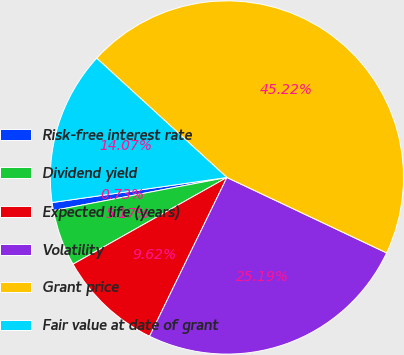Convert chart to OTSL. <chart><loc_0><loc_0><loc_500><loc_500><pie_chart><fcel>Risk-free interest rate<fcel>Dividend yield<fcel>Expected life (years)<fcel>Volatility<fcel>Grant price<fcel>Fair value at date of grant<nl><fcel>0.73%<fcel>5.17%<fcel>9.62%<fcel>25.19%<fcel>45.22%<fcel>14.07%<nl></chart> 